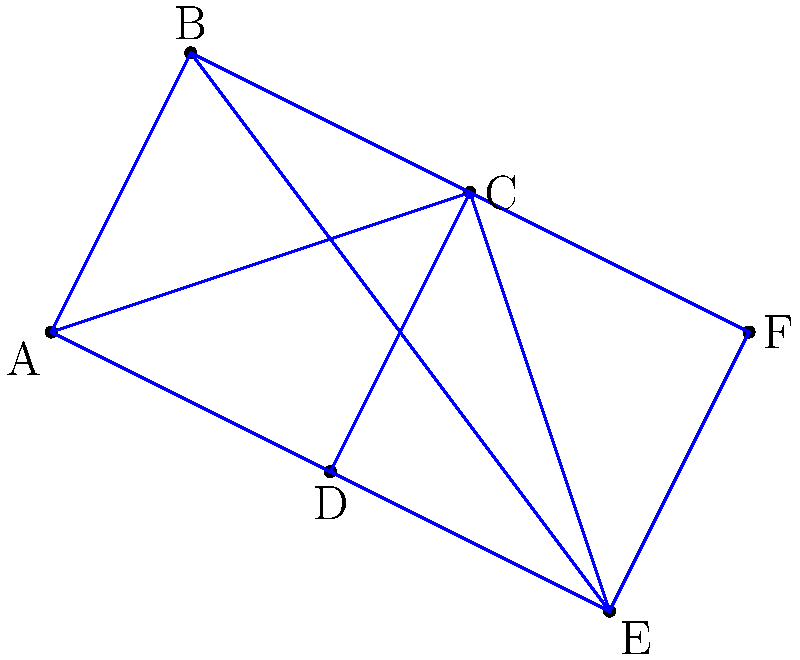As a government legal advisor focused on national security, you are tasked with designing a cost-effective surveillance system across a nation. The graph represents potential surveillance points (vertices) and the cost of connecting them (edge weights). What is the total cost of implementing a minimum spanning tree for this surveillance network? To find the minimum spanning tree (MST) and its total cost, we can use Kruskal's algorithm:

1. Sort all edges by weight in ascending order:
   EF (2), CF (3), CE (4), AC (5), DE (5), CD (6), AB (7), AE (7), AD (8), BC (9)

2. Add edges to the MST, skipping those that create cycles:
   - Add EF (2)
   - Add CF (3)
   - Add CE (4)
   - Add AC (5)
   - Skip DE (5) as it creates a cycle
   - Skip CD (6) as it creates a cycle
   - Add AB (7)

3. The MST is now complete with 5 edges (for 6 vertices).

4. Calculate the total cost by summing the weights of the selected edges:
   $$\text{Total Cost} = 2 + 3 + 4 + 5 + 7 = 21$$

Therefore, the minimum cost to implement the surveillance network is 21 units.
Answer: 21 units 